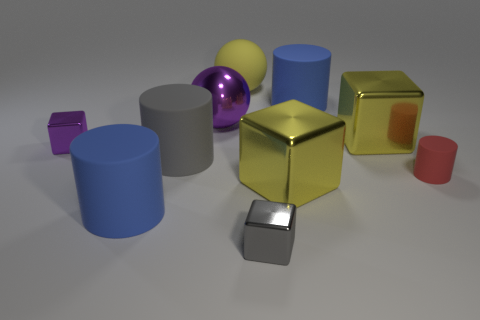What number of small gray cubes are to the left of the yellow block that is on the left side of the blue rubber object that is on the right side of the tiny gray metallic object?
Provide a succinct answer. 1. What number of things are either small shiny cubes that are to the right of the big purple sphere or metallic objects?
Your answer should be compact. 5. Does the block that is on the left side of the purple metallic sphere have the same color as the large metallic ball?
Keep it short and to the point. Yes. What shape is the big blue rubber object that is behind the big cube behind the tiny purple object?
Offer a very short reply. Cylinder. Is the number of red cylinders that are behind the yellow sphere less than the number of small red cylinders in front of the small purple cube?
Your answer should be compact. Yes. There is another gray object that is the same shape as the small rubber object; what size is it?
Make the answer very short. Large. What number of things are either big blue matte things behind the gray rubber cylinder or tiny things that are on the left side of the big yellow rubber ball?
Offer a terse response. 2. Does the red rubber object have the same size as the purple sphere?
Give a very brief answer. No. Is the number of large gray things greater than the number of tiny red cubes?
Offer a terse response. Yes. How many other things are the same color as the big matte sphere?
Offer a very short reply. 2. 